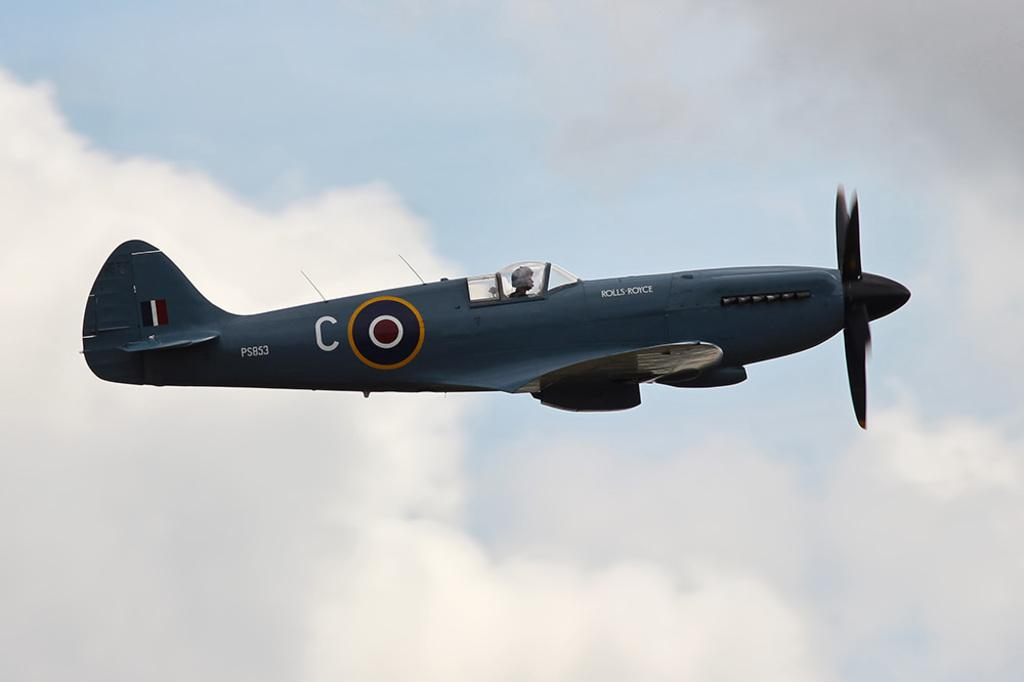<image>
Share a concise interpretation of the image provided. a plane with the letter C on the side 